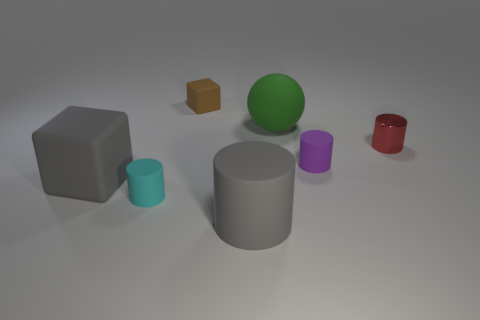What is the texture of the objects and how does the lighting affect their appearance? The objects exhibit various textures, ranging from matte to smooth surfaces. The lighting casts soft shadows and highlights, accentuating the shapes and textures of the objects, and giving the scene a calm and uniform appearance. Do the shadows reveal anything about the light source? Yes, the shadows are relatively soft and diffuse, indicating that the light source is not extremely close and may be quite large or diffused, possibly simulating an overcast sky or softbox lighting used in photography. 